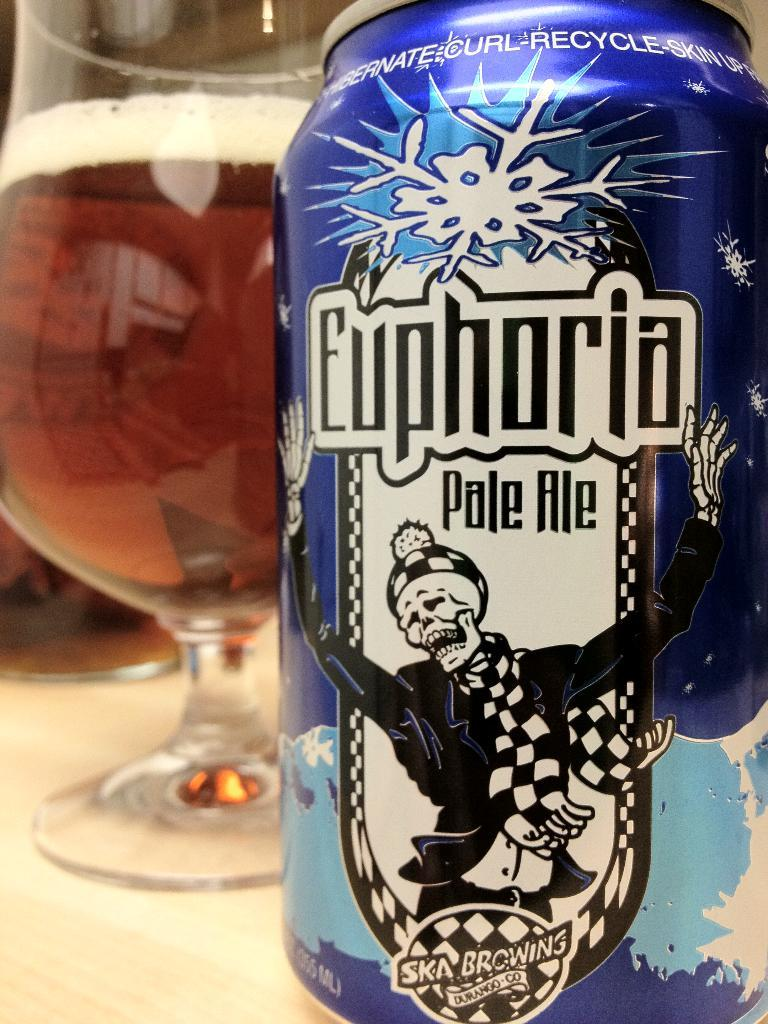<image>
Offer a succinct explanation of the picture presented. A blue can of Euphoria pale ale sits next to a glass. 